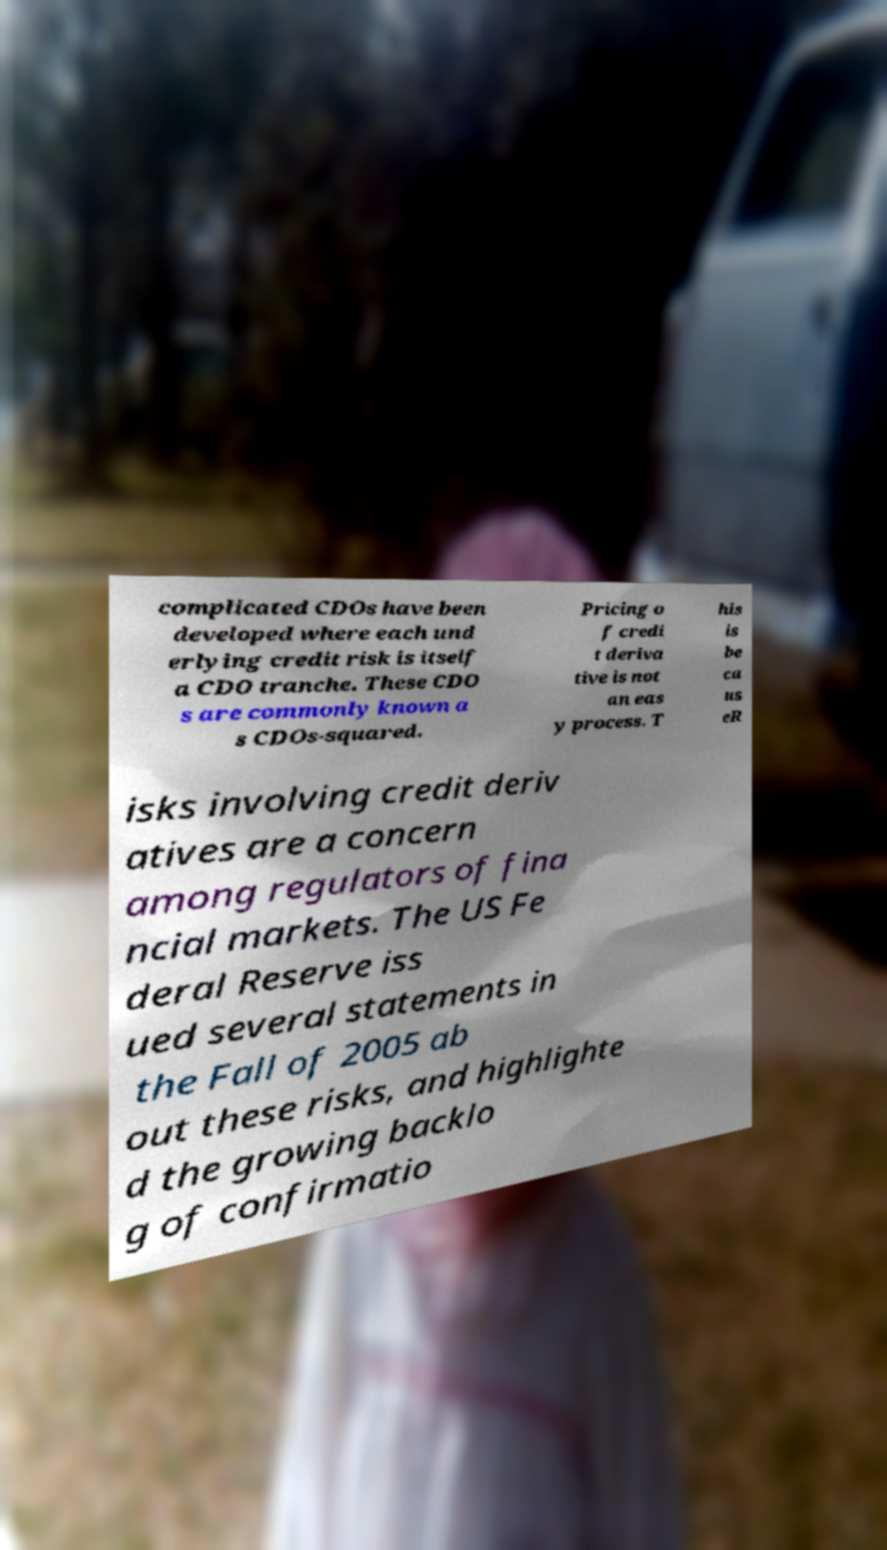What messages or text are displayed in this image? I need them in a readable, typed format. complicated CDOs have been developed where each und erlying credit risk is itself a CDO tranche. These CDO s are commonly known a s CDOs-squared. Pricing o f credi t deriva tive is not an eas y process. T his is be ca us eR isks involving credit deriv atives are a concern among regulators of fina ncial markets. The US Fe deral Reserve iss ued several statements in the Fall of 2005 ab out these risks, and highlighte d the growing backlo g of confirmatio 